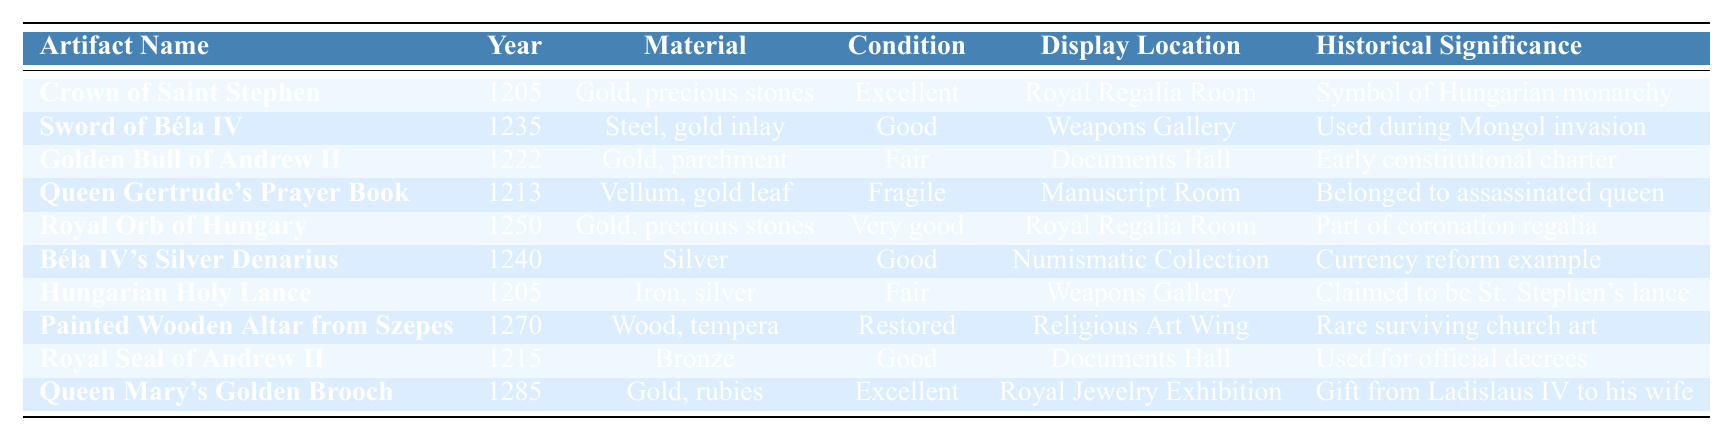What is the material of the Crown of Saint Stephen? The table shows the row for the Crown of Saint Stephen, and under the "Material" column, it states "Gold, precious stones."
Answer: Gold, precious stones Which artifact is displayed in the Manuscript Room? Referring to the "Display Location" column, the artifact listed for the Manuscript Room is "Queen Gertrude's Prayer Book."
Answer: Queen Gertrude's Prayer Book What is the condition of the Royal Orb of Hungary? Checking the "Condition" column for the "Royal Orb of Hungary," it lists the condition as "Very good."
Answer: Very good How many artifacts have an "Excellent" condition rating? By examining the "Condition" column, there are two artifacts listed as "Excellent": "Crown of Saint Stephen" and "Queen Mary's Golden Brooch."
Answer: 2 In which year was the Painted Wooden Altar from Szepes created? The "Year" column shows that the Painted Wooden Altar from Szepes was created in "1270."
Answer: 1270 Is the Sword of Béla IV made of gold? The "Material" column for the Sword of Béla IV lists "Steel, gold inlay," indicating that while it contains gold, it is primarily made of steel. Based on this, the answer is no.
Answer: No What artifact has the historical significance related to St. Stephen? The table specifies that the "Hungarian Holy Lance" is claimed to be St. Stephen's lance under the "Historical Significance" column.
Answer: Hungarian Holy Lance Which artifact was used for official decrees? Looking at the "Historical Significance" for the Royal Seal of Andrew II, it states that it was "Used for official decrees."
Answer: Royal Seal of Andrew II Identify the artifact made of iron. The only artifact made of iron, as per the "Material" column, is the "Hungarian Holy Lance."
Answer: Hungarian Holy Lance How many items are in the collection from the 13th century? The table lists artifacts from the years 1205 to 1285, totaling 10 items, all of which are from the 13th century as well.
Answer: 10 What is the average year of the artifacts displayed in the Royal Regalia Room? The artifacts in the Royal Regalia Room are "Crown of Saint Stephen" (1205) and "Royal Orb of Hungary" (1250). The average year is calculated as (1205 + 1250)/2 = 1227.5.
Answer: 1227.5 